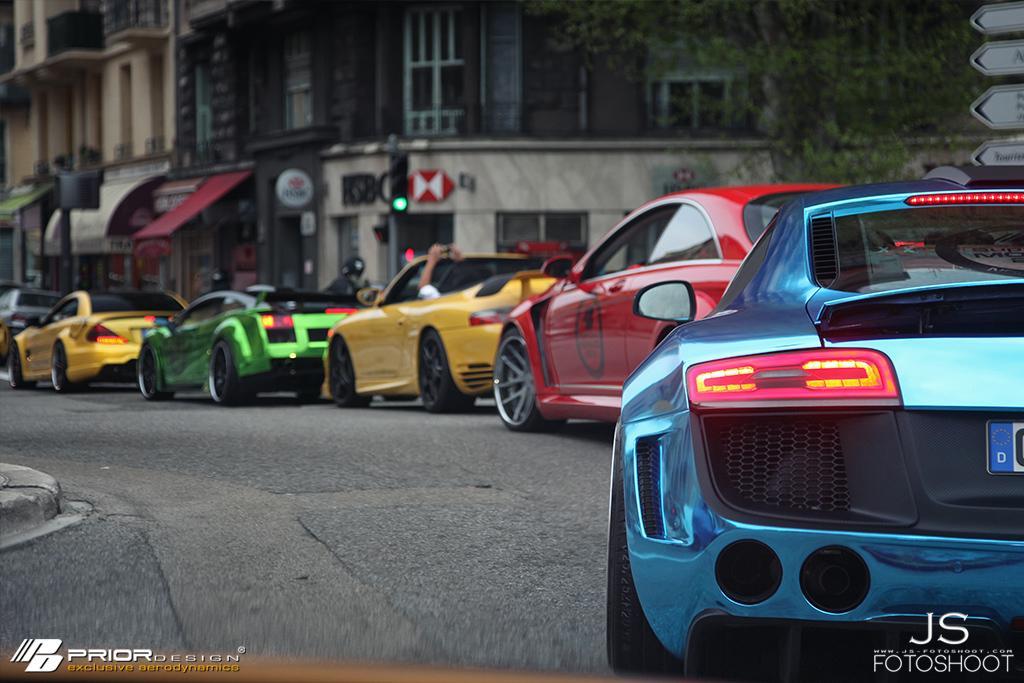How would you summarize this image in a sentence or two? In this image we can see the colorful cars on the road. We can also see some tail lights lightning. In the background we can see the buildings. There is a sign board and also a traffic signal light pole. We can also see the tree. At the bottom there is logo and also the text. 